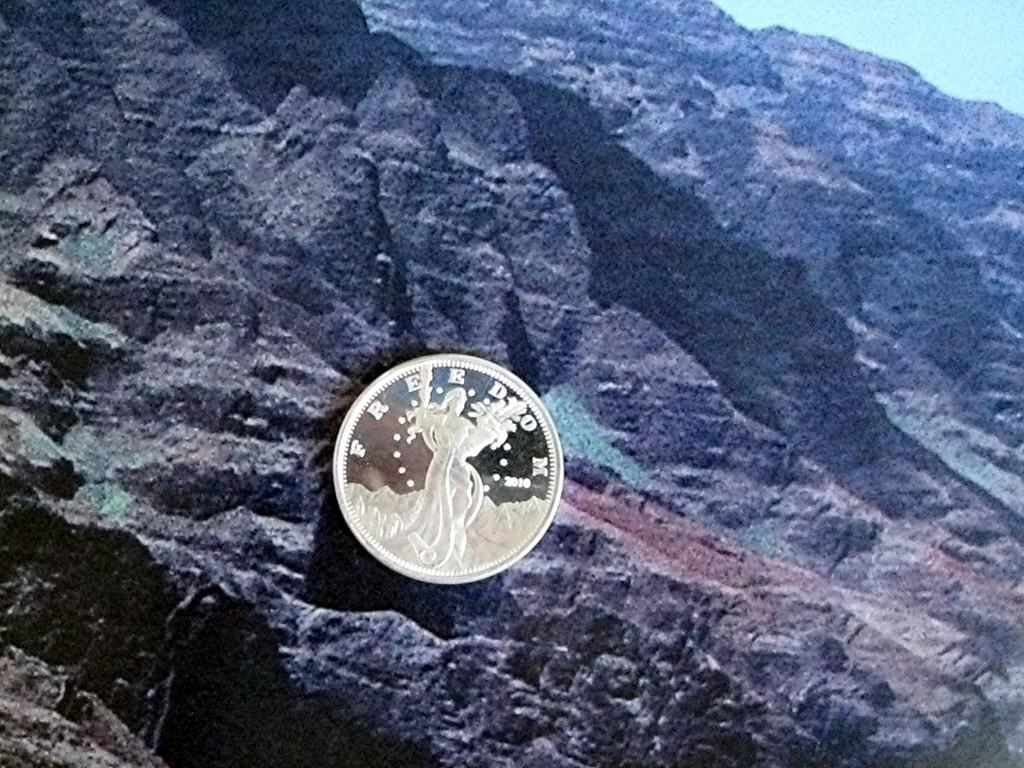<image>
Render a clear and concise summary of the photo. A small gold coin that says FREEDOM across the top is in front of a rocky background. 